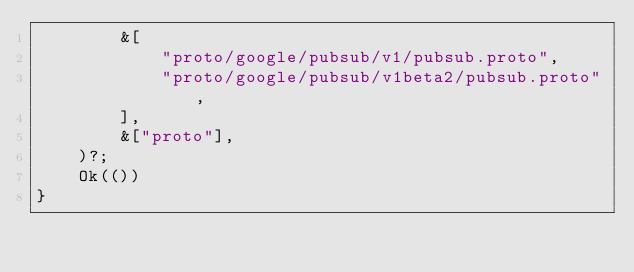<code> <loc_0><loc_0><loc_500><loc_500><_Rust_>        &[
            "proto/google/pubsub/v1/pubsub.proto",
            "proto/google/pubsub/v1beta2/pubsub.proto",
        ],
        &["proto"],
    )?;
    Ok(())
}
</code> 